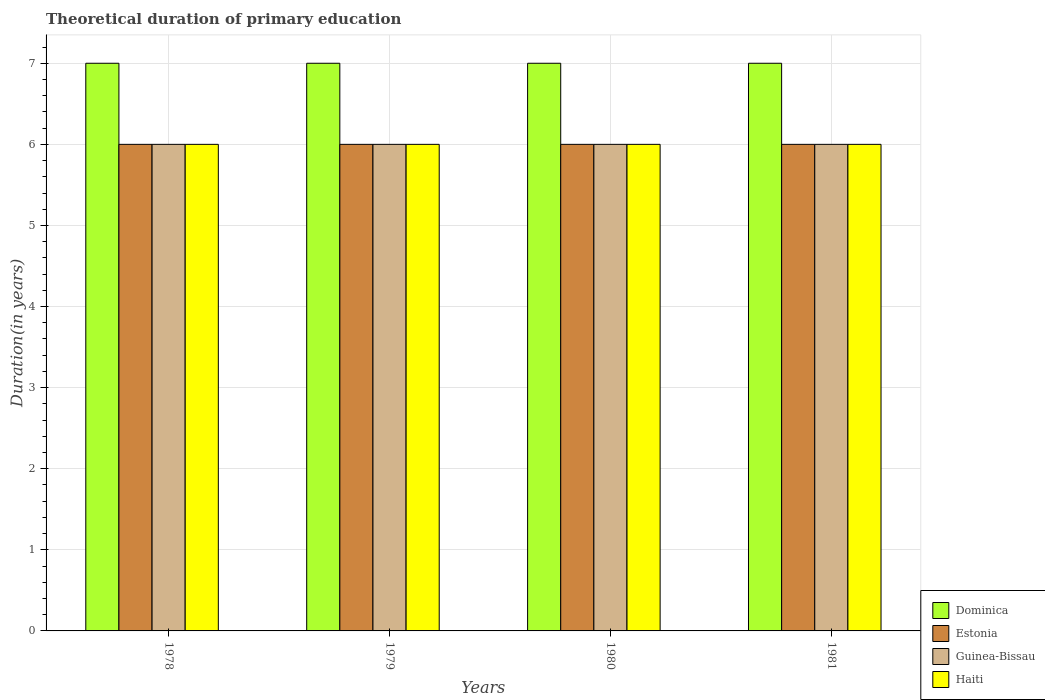How many different coloured bars are there?
Your response must be concise. 4. How many groups of bars are there?
Your answer should be compact. 4. Are the number of bars per tick equal to the number of legend labels?
Provide a succinct answer. Yes. Are the number of bars on each tick of the X-axis equal?
Make the answer very short. Yes. How many bars are there on the 3rd tick from the left?
Make the answer very short. 4. What is the label of the 4th group of bars from the left?
Make the answer very short. 1981. In how many cases, is the number of bars for a given year not equal to the number of legend labels?
Ensure brevity in your answer.  0. What is the total theoretical duration of primary education in Dominica in 1978?
Keep it short and to the point. 7. In which year was the total theoretical duration of primary education in Guinea-Bissau maximum?
Make the answer very short. 1978. In which year was the total theoretical duration of primary education in Guinea-Bissau minimum?
Make the answer very short. 1978. What is the total total theoretical duration of primary education in Dominica in the graph?
Your response must be concise. 28. In the year 1979, what is the difference between the total theoretical duration of primary education in Dominica and total theoretical duration of primary education in Estonia?
Ensure brevity in your answer.  1. In how many years, is the total theoretical duration of primary education in Guinea-Bissau greater than 0.6000000000000001 years?
Keep it short and to the point. 4. Is it the case that in every year, the sum of the total theoretical duration of primary education in Estonia and total theoretical duration of primary education in Dominica is greater than the sum of total theoretical duration of primary education in Guinea-Bissau and total theoretical duration of primary education in Haiti?
Ensure brevity in your answer.  Yes. What does the 4th bar from the left in 1979 represents?
Offer a terse response. Haiti. What does the 4th bar from the right in 1981 represents?
Your response must be concise. Dominica. Is it the case that in every year, the sum of the total theoretical duration of primary education in Guinea-Bissau and total theoretical duration of primary education in Haiti is greater than the total theoretical duration of primary education in Estonia?
Offer a terse response. Yes. How many years are there in the graph?
Make the answer very short. 4. What is the difference between two consecutive major ticks on the Y-axis?
Give a very brief answer. 1. How many legend labels are there?
Your answer should be compact. 4. What is the title of the graph?
Offer a very short reply. Theoretical duration of primary education. Does "Guinea-Bissau" appear as one of the legend labels in the graph?
Keep it short and to the point. Yes. What is the label or title of the X-axis?
Make the answer very short. Years. What is the label or title of the Y-axis?
Offer a terse response. Duration(in years). What is the Duration(in years) in Guinea-Bissau in 1978?
Provide a succinct answer. 6. What is the Duration(in years) in Haiti in 1978?
Your answer should be very brief. 6. What is the Duration(in years) in Guinea-Bissau in 1979?
Keep it short and to the point. 6. What is the Duration(in years) of Haiti in 1979?
Provide a short and direct response. 6. What is the Duration(in years) of Dominica in 1980?
Give a very brief answer. 7. What is the Duration(in years) in Guinea-Bissau in 1980?
Make the answer very short. 6. What is the Duration(in years) of Guinea-Bissau in 1981?
Your answer should be compact. 6. Across all years, what is the maximum Duration(in years) of Dominica?
Offer a terse response. 7. Across all years, what is the maximum Duration(in years) of Guinea-Bissau?
Your answer should be compact. 6. Across all years, what is the maximum Duration(in years) of Haiti?
Offer a very short reply. 6. Across all years, what is the minimum Duration(in years) in Dominica?
Provide a succinct answer. 7. Across all years, what is the minimum Duration(in years) in Guinea-Bissau?
Make the answer very short. 6. Across all years, what is the minimum Duration(in years) of Haiti?
Give a very brief answer. 6. What is the total Duration(in years) in Dominica in the graph?
Your answer should be compact. 28. What is the total Duration(in years) of Estonia in the graph?
Offer a terse response. 24. What is the total Duration(in years) in Haiti in the graph?
Your answer should be very brief. 24. What is the difference between the Duration(in years) of Dominica in 1978 and that in 1979?
Ensure brevity in your answer.  0. What is the difference between the Duration(in years) in Guinea-Bissau in 1978 and that in 1979?
Offer a very short reply. 0. What is the difference between the Duration(in years) in Haiti in 1978 and that in 1979?
Provide a short and direct response. 0. What is the difference between the Duration(in years) in Dominica in 1978 and that in 1980?
Make the answer very short. 0. What is the difference between the Duration(in years) in Estonia in 1978 and that in 1980?
Offer a terse response. 0. What is the difference between the Duration(in years) of Haiti in 1978 and that in 1981?
Your answer should be very brief. 0. What is the difference between the Duration(in years) of Dominica in 1979 and that in 1980?
Your answer should be compact. 0. What is the difference between the Duration(in years) of Estonia in 1979 and that in 1980?
Give a very brief answer. 0. What is the difference between the Duration(in years) in Guinea-Bissau in 1979 and that in 1980?
Give a very brief answer. 0. What is the difference between the Duration(in years) in Haiti in 1979 and that in 1980?
Provide a succinct answer. 0. What is the difference between the Duration(in years) of Dominica in 1979 and that in 1981?
Offer a terse response. 0. What is the difference between the Duration(in years) in Guinea-Bissau in 1979 and that in 1981?
Provide a succinct answer. 0. What is the difference between the Duration(in years) of Dominica in 1980 and that in 1981?
Give a very brief answer. 0. What is the difference between the Duration(in years) of Guinea-Bissau in 1980 and that in 1981?
Your answer should be compact. 0. What is the difference between the Duration(in years) of Haiti in 1980 and that in 1981?
Your response must be concise. 0. What is the difference between the Duration(in years) in Dominica in 1978 and the Duration(in years) in Estonia in 1979?
Keep it short and to the point. 1. What is the difference between the Duration(in years) in Dominica in 1978 and the Duration(in years) in Guinea-Bissau in 1979?
Make the answer very short. 1. What is the difference between the Duration(in years) in Dominica in 1978 and the Duration(in years) in Haiti in 1979?
Provide a short and direct response. 1. What is the difference between the Duration(in years) in Estonia in 1978 and the Duration(in years) in Guinea-Bissau in 1979?
Your answer should be very brief. 0. What is the difference between the Duration(in years) of Estonia in 1978 and the Duration(in years) of Haiti in 1979?
Offer a terse response. 0. What is the difference between the Duration(in years) in Guinea-Bissau in 1978 and the Duration(in years) in Haiti in 1979?
Offer a very short reply. 0. What is the difference between the Duration(in years) of Dominica in 1978 and the Duration(in years) of Estonia in 1980?
Your answer should be very brief. 1. What is the difference between the Duration(in years) in Dominica in 1978 and the Duration(in years) in Haiti in 1980?
Offer a terse response. 1. What is the difference between the Duration(in years) of Estonia in 1978 and the Duration(in years) of Guinea-Bissau in 1980?
Give a very brief answer. 0. What is the difference between the Duration(in years) of Guinea-Bissau in 1978 and the Duration(in years) of Haiti in 1980?
Provide a succinct answer. 0. What is the difference between the Duration(in years) of Dominica in 1978 and the Duration(in years) of Estonia in 1981?
Your response must be concise. 1. What is the difference between the Duration(in years) of Dominica in 1978 and the Duration(in years) of Haiti in 1981?
Offer a very short reply. 1. What is the difference between the Duration(in years) of Estonia in 1978 and the Duration(in years) of Guinea-Bissau in 1981?
Keep it short and to the point. 0. What is the difference between the Duration(in years) of Estonia in 1978 and the Duration(in years) of Haiti in 1981?
Offer a very short reply. 0. What is the difference between the Duration(in years) of Guinea-Bissau in 1978 and the Duration(in years) of Haiti in 1981?
Offer a very short reply. 0. What is the difference between the Duration(in years) in Dominica in 1979 and the Duration(in years) in Guinea-Bissau in 1980?
Offer a very short reply. 1. What is the difference between the Duration(in years) in Dominica in 1979 and the Duration(in years) in Haiti in 1980?
Offer a terse response. 1. What is the difference between the Duration(in years) of Estonia in 1979 and the Duration(in years) of Guinea-Bissau in 1980?
Your response must be concise. 0. What is the difference between the Duration(in years) in Estonia in 1979 and the Duration(in years) in Haiti in 1980?
Offer a terse response. 0. What is the difference between the Duration(in years) in Guinea-Bissau in 1979 and the Duration(in years) in Haiti in 1980?
Keep it short and to the point. 0. What is the difference between the Duration(in years) of Dominica in 1979 and the Duration(in years) of Estonia in 1981?
Your answer should be very brief. 1. What is the difference between the Duration(in years) in Dominica in 1979 and the Duration(in years) in Guinea-Bissau in 1981?
Keep it short and to the point. 1. What is the difference between the Duration(in years) in Estonia in 1979 and the Duration(in years) in Guinea-Bissau in 1981?
Your answer should be very brief. 0. What is the difference between the Duration(in years) in Guinea-Bissau in 1979 and the Duration(in years) in Haiti in 1981?
Make the answer very short. 0. What is the difference between the Duration(in years) in Dominica in 1980 and the Duration(in years) in Estonia in 1981?
Offer a very short reply. 1. What is the difference between the Duration(in years) of Dominica in 1980 and the Duration(in years) of Guinea-Bissau in 1981?
Keep it short and to the point. 1. What is the difference between the Duration(in years) of Estonia in 1980 and the Duration(in years) of Guinea-Bissau in 1981?
Your answer should be very brief. 0. What is the difference between the Duration(in years) of Estonia in 1980 and the Duration(in years) of Haiti in 1981?
Your answer should be very brief. 0. What is the difference between the Duration(in years) of Guinea-Bissau in 1980 and the Duration(in years) of Haiti in 1981?
Offer a terse response. 0. What is the average Duration(in years) of Dominica per year?
Your response must be concise. 7. What is the average Duration(in years) in Guinea-Bissau per year?
Your answer should be very brief. 6. In the year 1978, what is the difference between the Duration(in years) in Dominica and Duration(in years) in Estonia?
Make the answer very short. 1. In the year 1978, what is the difference between the Duration(in years) in Dominica and Duration(in years) in Guinea-Bissau?
Provide a succinct answer. 1. In the year 1978, what is the difference between the Duration(in years) of Guinea-Bissau and Duration(in years) of Haiti?
Your response must be concise. 0. In the year 1979, what is the difference between the Duration(in years) of Dominica and Duration(in years) of Estonia?
Your answer should be very brief. 1. In the year 1979, what is the difference between the Duration(in years) of Dominica and Duration(in years) of Guinea-Bissau?
Your response must be concise. 1. In the year 1979, what is the difference between the Duration(in years) of Dominica and Duration(in years) of Haiti?
Offer a terse response. 1. In the year 1979, what is the difference between the Duration(in years) in Estonia and Duration(in years) in Haiti?
Provide a short and direct response. 0. In the year 1979, what is the difference between the Duration(in years) of Guinea-Bissau and Duration(in years) of Haiti?
Keep it short and to the point. 0. In the year 1980, what is the difference between the Duration(in years) in Dominica and Duration(in years) in Guinea-Bissau?
Offer a very short reply. 1. In the year 1980, what is the difference between the Duration(in years) in Estonia and Duration(in years) in Guinea-Bissau?
Provide a succinct answer. 0. In the year 1980, what is the difference between the Duration(in years) of Guinea-Bissau and Duration(in years) of Haiti?
Provide a short and direct response. 0. In the year 1981, what is the difference between the Duration(in years) of Dominica and Duration(in years) of Estonia?
Keep it short and to the point. 1. In the year 1981, what is the difference between the Duration(in years) of Dominica and Duration(in years) of Guinea-Bissau?
Offer a very short reply. 1. In the year 1981, what is the difference between the Duration(in years) in Dominica and Duration(in years) in Haiti?
Your answer should be very brief. 1. In the year 1981, what is the difference between the Duration(in years) in Estonia and Duration(in years) in Haiti?
Provide a succinct answer. 0. What is the ratio of the Duration(in years) of Estonia in 1978 to that in 1979?
Your answer should be compact. 1. What is the ratio of the Duration(in years) of Guinea-Bissau in 1978 to that in 1981?
Give a very brief answer. 1. What is the ratio of the Duration(in years) of Haiti in 1978 to that in 1981?
Keep it short and to the point. 1. What is the ratio of the Duration(in years) in Dominica in 1979 to that in 1980?
Give a very brief answer. 1. What is the ratio of the Duration(in years) of Guinea-Bissau in 1979 to that in 1980?
Your response must be concise. 1. What is the ratio of the Duration(in years) of Dominica in 1979 to that in 1981?
Provide a short and direct response. 1. What is the ratio of the Duration(in years) in Estonia in 1979 to that in 1981?
Give a very brief answer. 1. What is the ratio of the Duration(in years) of Dominica in 1980 to that in 1981?
Your answer should be very brief. 1. What is the ratio of the Duration(in years) in Estonia in 1980 to that in 1981?
Provide a succinct answer. 1. What is the ratio of the Duration(in years) of Guinea-Bissau in 1980 to that in 1981?
Give a very brief answer. 1. What is the difference between the highest and the second highest Duration(in years) of Dominica?
Keep it short and to the point. 0. What is the difference between the highest and the second highest Duration(in years) of Estonia?
Offer a terse response. 0. What is the difference between the highest and the second highest Duration(in years) in Guinea-Bissau?
Make the answer very short. 0. What is the difference between the highest and the lowest Duration(in years) in Estonia?
Your response must be concise. 0. 